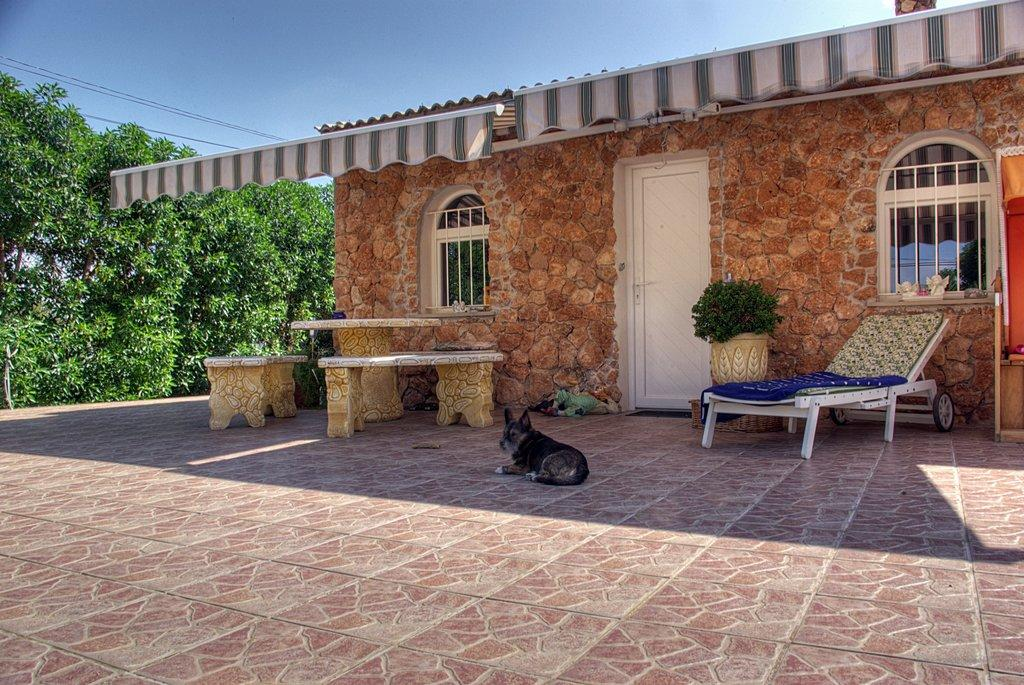What type of structure is present in the picture? There is a house in the picture. What type of furniture is present in the picture? There are benches, a table, and a chair in the picture. What type of plant is present in the picture? There is a plant in a pot in the picture. What type of animal is present in the picture? There is a dog in the picture. What type of natural elements are present in the picture? There are trees in the picture. What is the color of the sky in the picture? The sky is blue in the picture. What type of meal is being prepared by the doctor in the picture? There is no doctor or meal preparation present in the picture. Can you tell me how many kitties are sitting on the benches in the picture? There are no kitties present in the picture. 